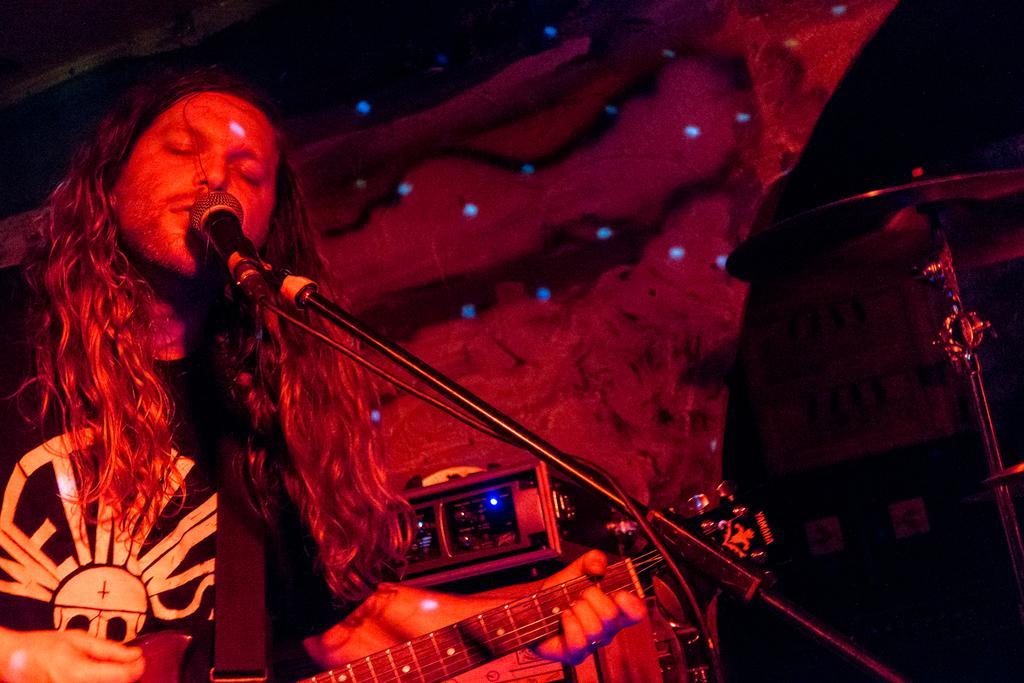Can you describe this image briefly? He is standing and his playing a musical instrument. 